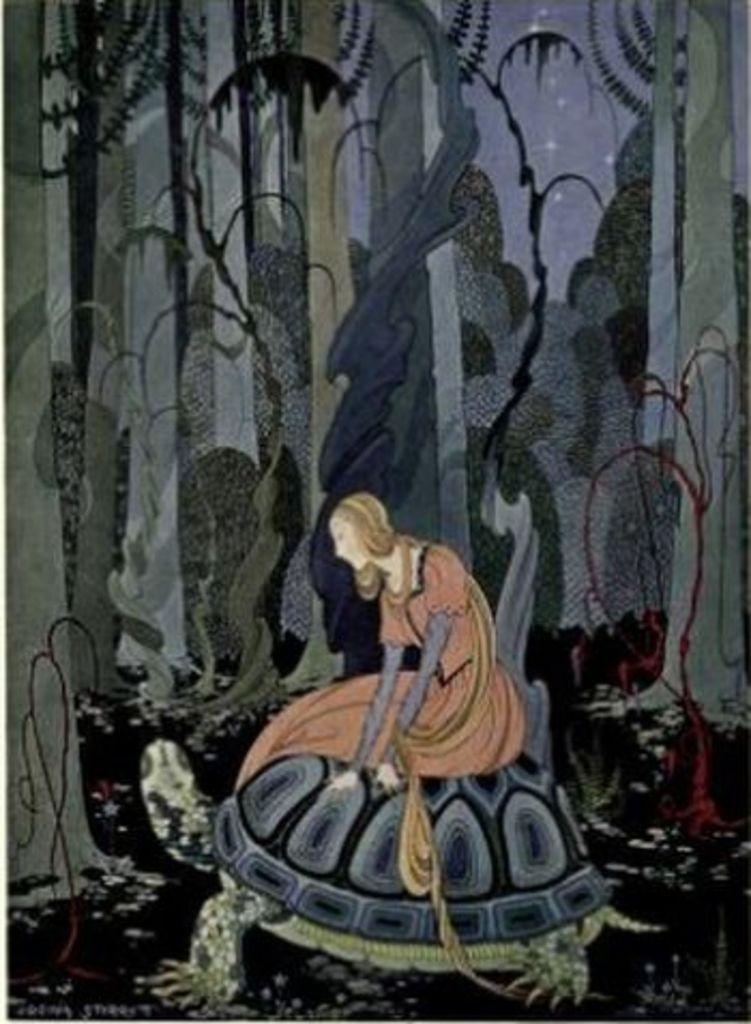What is the main subject of the image? There is a painting in the image. What is the painting depicting? The painting depicts a woman sitting on a tortoise. What can be seen in the background of the painting? There are trees and the sky visible in the background of the painting. Where is the tramp located in the image? There is no tramp present in the image; it features a painting of a woman sitting on a tortoise. What type of shop can be seen in the background of the painting? There is no shop depicted in the background of the painting; it only shows trees and the sky. 